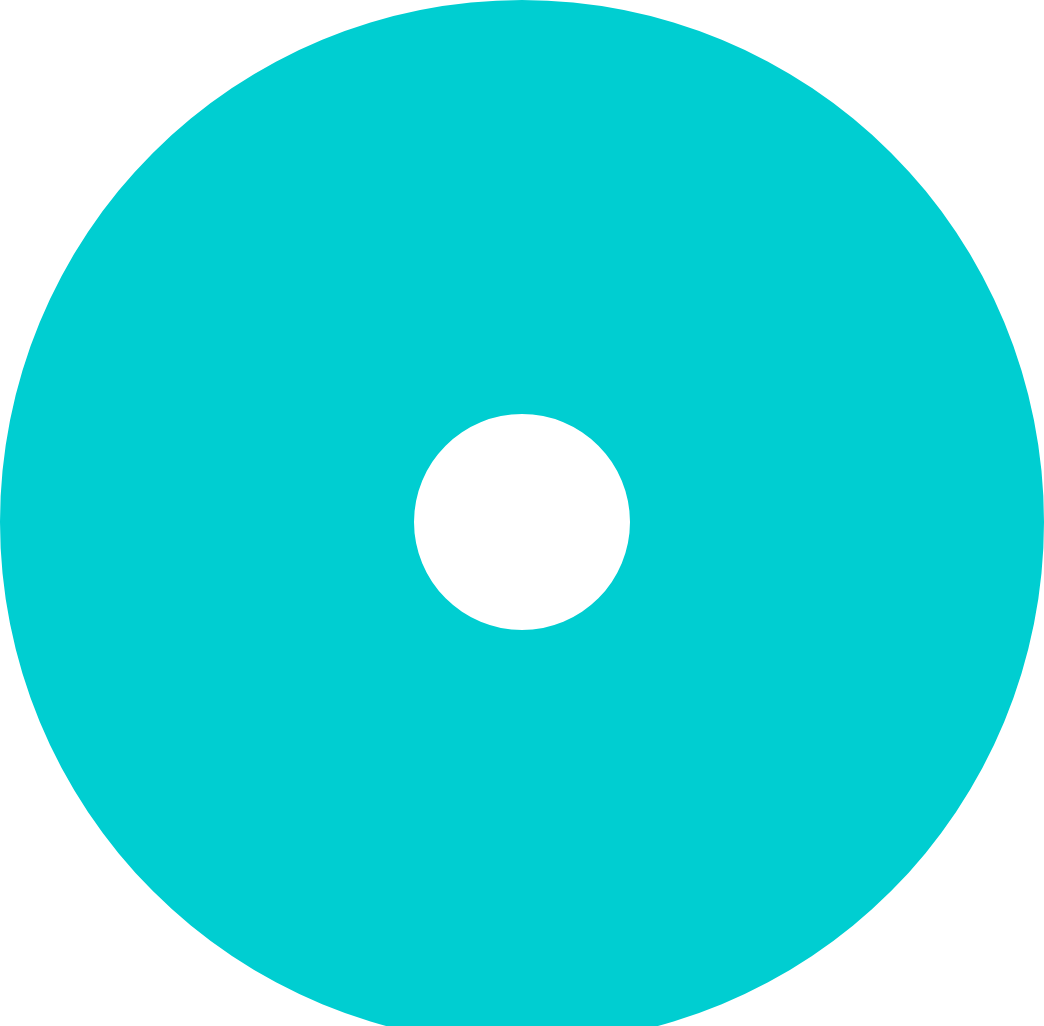Convert chart to OTSL. <chart><loc_0><loc_0><loc_500><loc_500><pie_chart><fcel>Employee stock plan<nl><fcel>100.0%<nl></chart> 